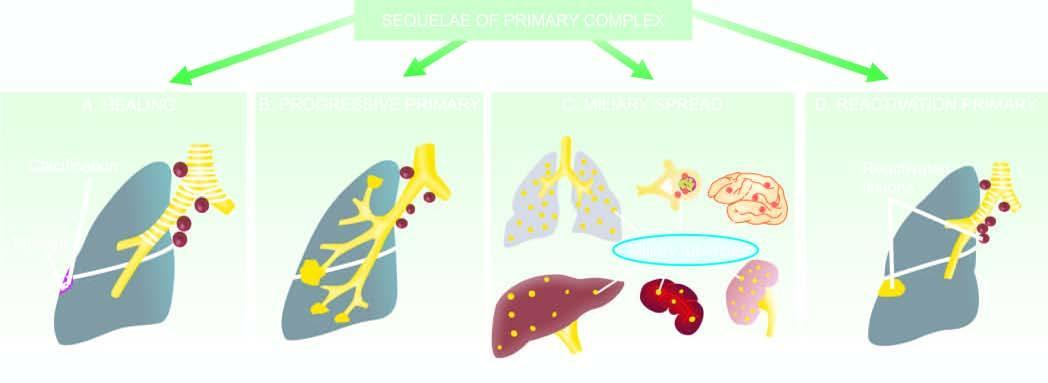did miliary spread to lungs, liver, spleen, kidneys and brain?
Answer the question using a single word or phrase. Yes 